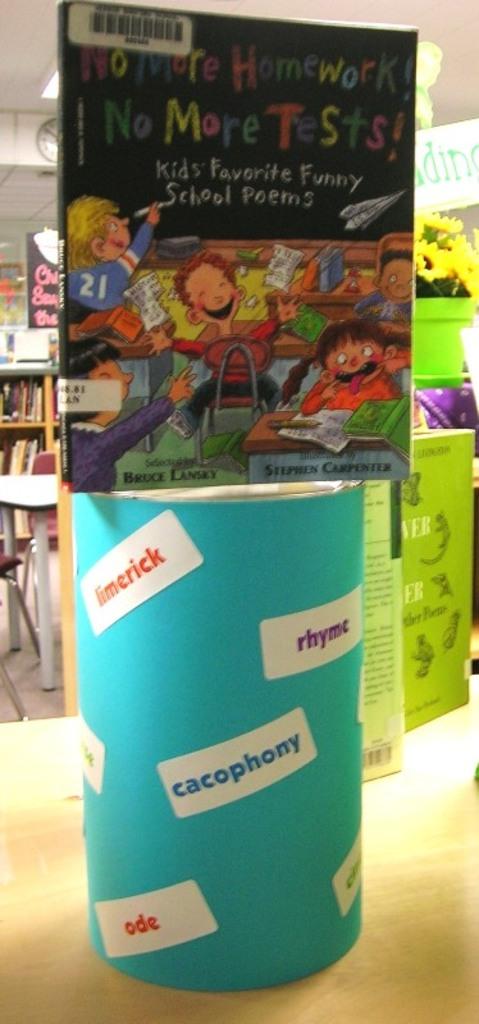What is the project protesting?
Give a very brief answer. No more homework or tests. Who wrote this book?
Provide a short and direct response. Bruce lansky. 